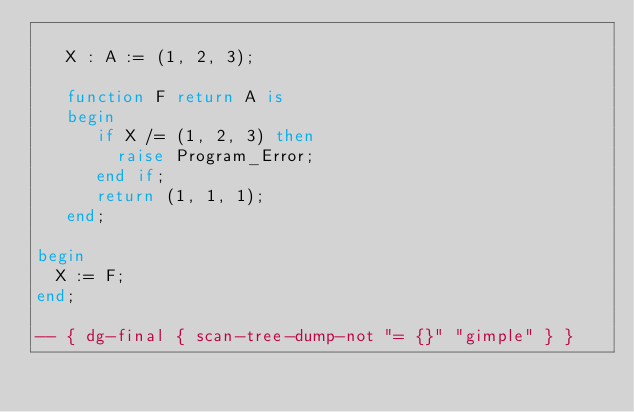Convert code to text. <code><loc_0><loc_0><loc_500><loc_500><_Ada_>
   X : A := (1, 2, 3);

   function F return A is
   begin
      if X /= (1, 2, 3) then
        raise Program_Error;
      end if;
      return (1, 1, 1);
   end;

begin
  X := F;
end;

-- { dg-final { scan-tree-dump-not "= {}" "gimple" } }
</code> 